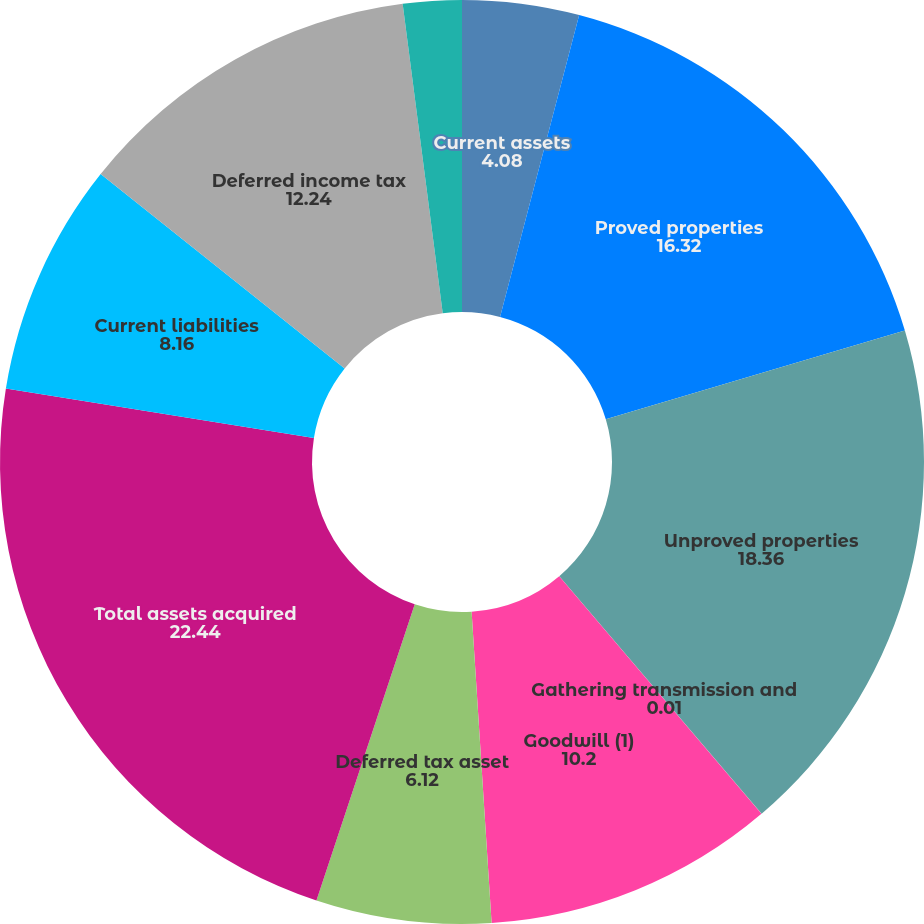Convert chart to OTSL. <chart><loc_0><loc_0><loc_500><loc_500><pie_chart><fcel>Current assets<fcel>Proved properties<fcel>Unproved properties<fcel>Gathering transmission and<fcel>Goodwill (1)<fcel>Deferred tax asset<fcel>Total assets acquired<fcel>Current liabilities<fcel>Deferred income tax<fcel>Other long-term obligations<nl><fcel>4.08%<fcel>16.32%<fcel>18.36%<fcel>0.01%<fcel>10.2%<fcel>6.12%<fcel>22.44%<fcel>8.16%<fcel>12.24%<fcel>2.05%<nl></chart> 